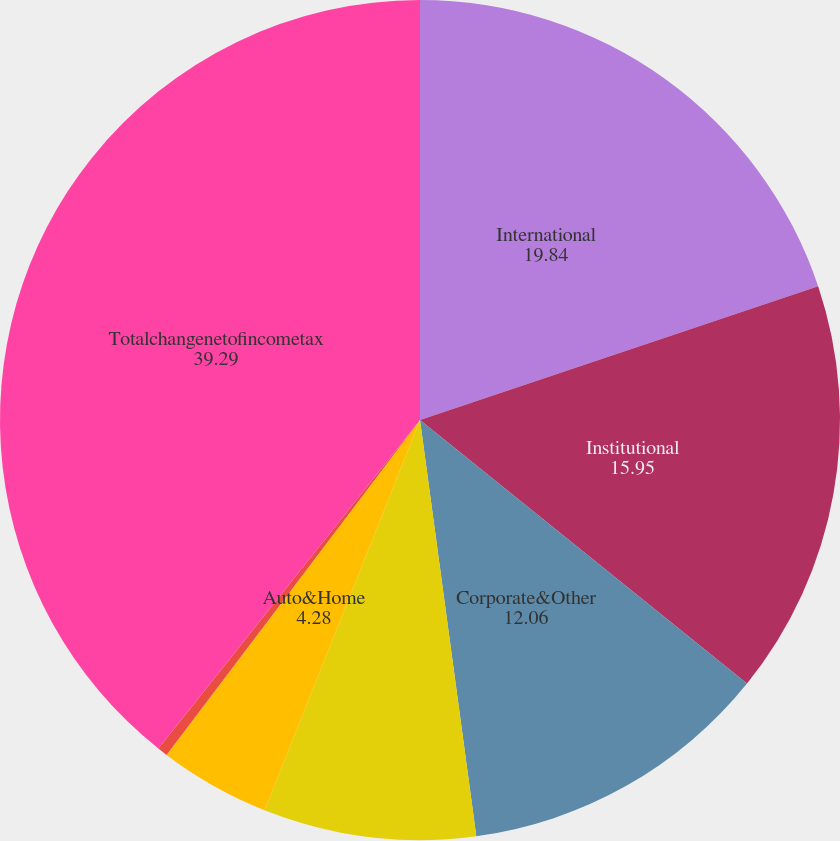Convert chart. <chart><loc_0><loc_0><loc_500><loc_500><pie_chart><fcel>International<fcel>Institutional<fcel>Corporate&Other<fcel>Individual<fcel>Auto&Home<fcel>Reinsurance<fcel>Totalchangenetofincometax<nl><fcel>19.84%<fcel>15.95%<fcel>12.06%<fcel>8.17%<fcel>4.28%<fcel>0.39%<fcel>39.29%<nl></chart> 